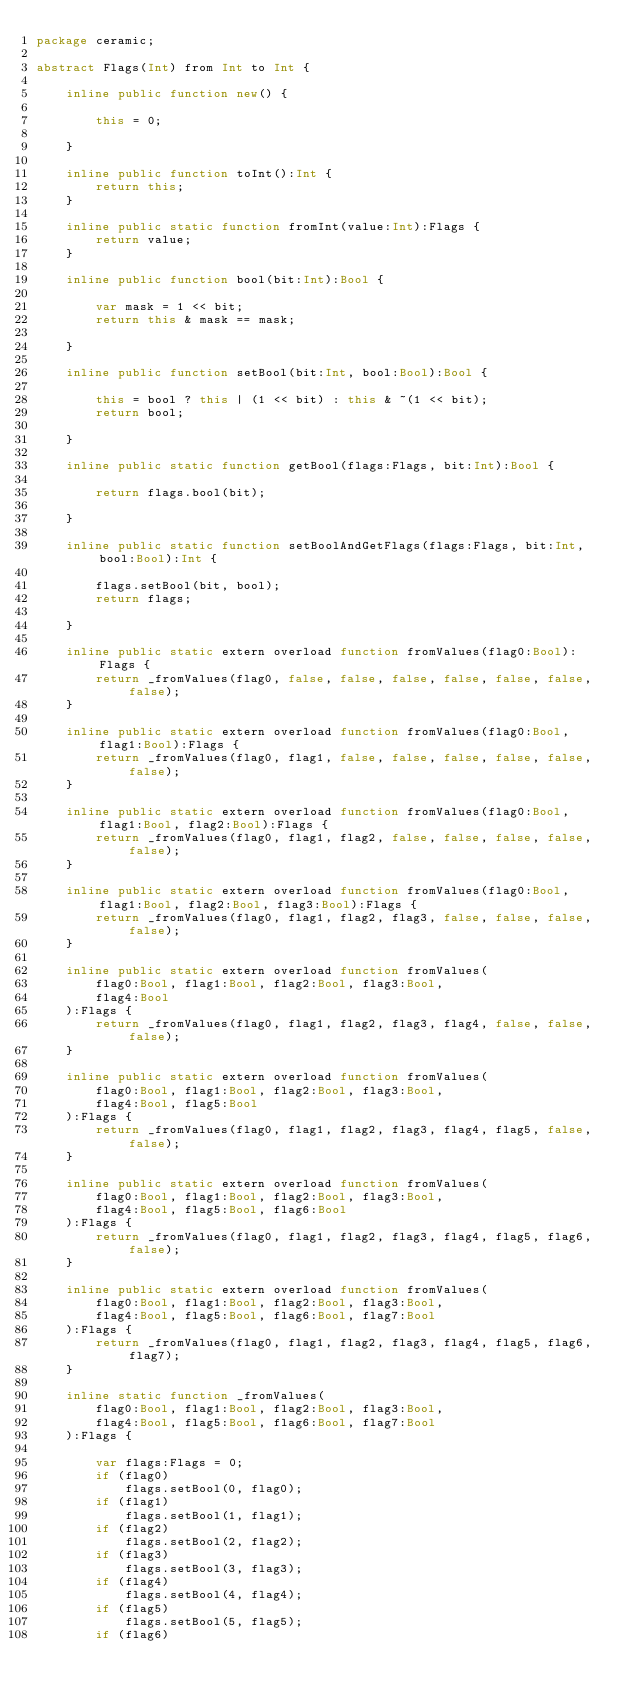Convert code to text. <code><loc_0><loc_0><loc_500><loc_500><_Haxe_>package ceramic;

abstract Flags(Int) from Int to Int {

    inline public function new() {

        this = 0;

    }

    inline public function toInt():Int {
        return this;
    }

    inline public static function fromInt(value:Int):Flags {
        return value;
    }

    inline public function bool(bit:Int):Bool {

        var mask = 1 << bit;
        return this & mask == mask;

    }

    inline public function setBool(bit:Int, bool:Bool):Bool {

        this = bool ? this | (1 << bit) : this & ~(1 << bit);
        return bool;

    }

    inline public static function getBool(flags:Flags, bit:Int):Bool {

        return flags.bool(bit);

    }

    inline public static function setBoolAndGetFlags(flags:Flags, bit:Int, bool:Bool):Int {

        flags.setBool(bit, bool);
        return flags;

    }

    inline public static extern overload function fromValues(flag0:Bool):Flags {
        return _fromValues(flag0, false, false, false, false, false, false, false);
    }

    inline public static extern overload function fromValues(flag0:Bool, flag1:Bool):Flags {
        return _fromValues(flag0, flag1, false, false, false, false, false, false);
    }

    inline public static extern overload function fromValues(flag0:Bool, flag1:Bool, flag2:Bool):Flags {
        return _fromValues(flag0, flag1, flag2, false, false, false, false, false);
    }

    inline public static extern overload function fromValues(flag0:Bool, flag1:Bool, flag2:Bool, flag3:Bool):Flags {
        return _fromValues(flag0, flag1, flag2, flag3, false, false, false, false);
    }

    inline public static extern overload function fromValues(
        flag0:Bool, flag1:Bool, flag2:Bool, flag3:Bool,
        flag4:Bool
    ):Flags {
        return _fromValues(flag0, flag1, flag2, flag3, flag4, false, false, false);
    }

    inline public static extern overload function fromValues(
        flag0:Bool, flag1:Bool, flag2:Bool, flag3:Bool,
        flag4:Bool, flag5:Bool
    ):Flags {
        return _fromValues(flag0, flag1, flag2, flag3, flag4, flag5, false, false);
    }

    inline public static extern overload function fromValues(
        flag0:Bool, flag1:Bool, flag2:Bool, flag3:Bool,
        flag4:Bool, flag5:Bool, flag6:Bool
    ):Flags {
        return _fromValues(flag0, flag1, flag2, flag3, flag4, flag5, flag6, false);
    }

    inline public static extern overload function fromValues(
        flag0:Bool, flag1:Bool, flag2:Bool, flag3:Bool,
        flag4:Bool, flag5:Bool, flag6:Bool, flag7:Bool
    ):Flags {
        return _fromValues(flag0, flag1, flag2, flag3, flag4, flag5, flag6, flag7);
    }

    inline static function _fromValues(
        flag0:Bool, flag1:Bool, flag2:Bool, flag3:Bool,
        flag4:Bool, flag5:Bool, flag6:Bool, flag7:Bool
    ):Flags {

        var flags:Flags = 0;
        if (flag0)
            flags.setBool(0, flag0);
        if (flag1)
            flags.setBool(1, flag1);
        if (flag2)
            flags.setBool(2, flag2);
        if (flag3)
            flags.setBool(3, flag3);
        if (flag4)
            flags.setBool(4, flag4);
        if (flag5)
            flags.setBool(5, flag5);
        if (flag6)</code> 